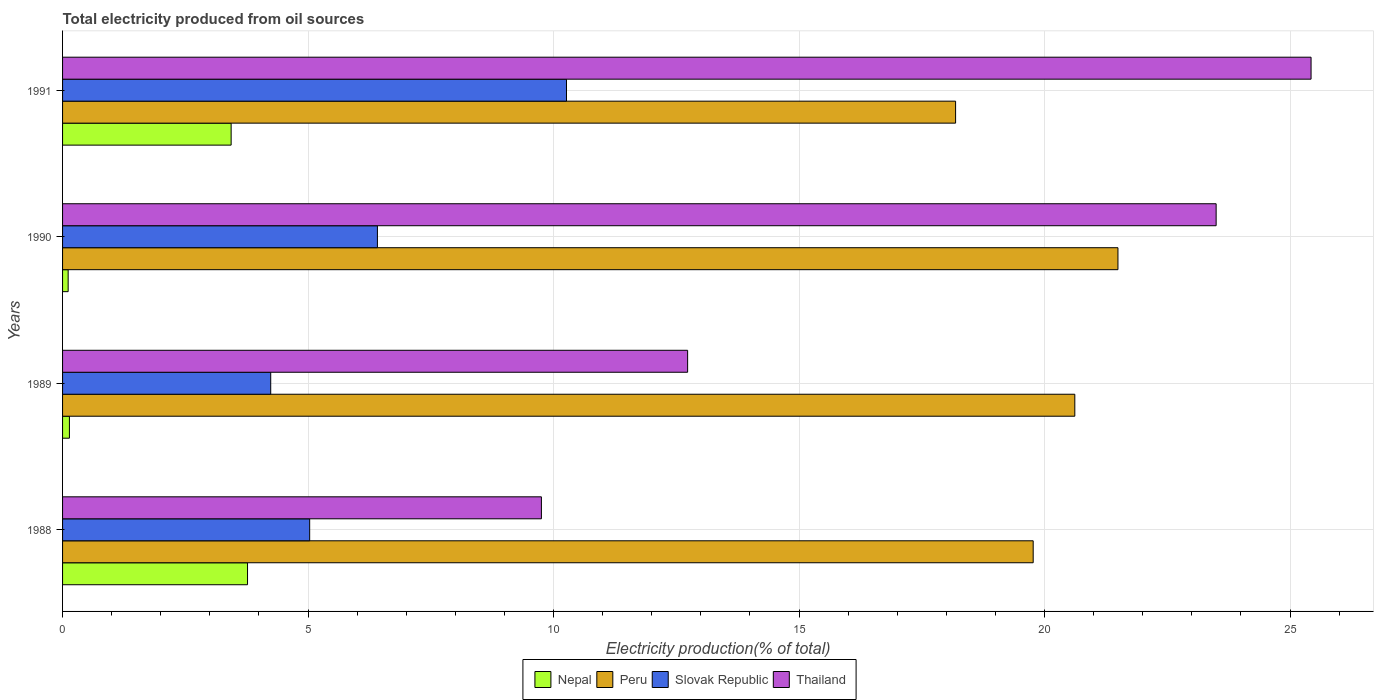How many different coloured bars are there?
Your answer should be compact. 4. How many groups of bars are there?
Offer a terse response. 4. Are the number of bars per tick equal to the number of legend labels?
Give a very brief answer. Yes. Are the number of bars on each tick of the Y-axis equal?
Your response must be concise. Yes. How many bars are there on the 4th tick from the top?
Make the answer very short. 4. What is the label of the 3rd group of bars from the top?
Offer a terse response. 1989. In how many cases, is the number of bars for a given year not equal to the number of legend labels?
Make the answer very short. 0. What is the total electricity produced in Slovak Republic in 1990?
Provide a succinct answer. 6.41. Across all years, what is the maximum total electricity produced in Nepal?
Make the answer very short. 3.77. Across all years, what is the minimum total electricity produced in Thailand?
Keep it short and to the point. 9.75. In which year was the total electricity produced in Peru maximum?
Keep it short and to the point. 1990. In which year was the total electricity produced in Slovak Republic minimum?
Give a very brief answer. 1989. What is the total total electricity produced in Thailand in the graph?
Keep it short and to the point. 71.41. What is the difference between the total electricity produced in Thailand in 1988 and that in 1991?
Provide a short and direct response. -15.68. What is the difference between the total electricity produced in Thailand in 1990 and the total electricity produced in Slovak Republic in 1991?
Give a very brief answer. 13.23. What is the average total electricity produced in Peru per year?
Ensure brevity in your answer.  20.02. In the year 1988, what is the difference between the total electricity produced in Peru and total electricity produced in Slovak Republic?
Provide a short and direct response. 14.74. In how many years, is the total electricity produced in Peru greater than 4 %?
Provide a succinct answer. 4. What is the ratio of the total electricity produced in Peru in 1990 to that in 1991?
Ensure brevity in your answer.  1.18. What is the difference between the highest and the second highest total electricity produced in Thailand?
Ensure brevity in your answer.  1.93. What is the difference between the highest and the lowest total electricity produced in Nepal?
Your answer should be very brief. 3.65. In how many years, is the total electricity produced in Slovak Republic greater than the average total electricity produced in Slovak Republic taken over all years?
Your response must be concise. 1. Is the sum of the total electricity produced in Slovak Republic in 1989 and 1990 greater than the maximum total electricity produced in Peru across all years?
Make the answer very short. No. Is it the case that in every year, the sum of the total electricity produced in Slovak Republic and total electricity produced in Nepal is greater than the sum of total electricity produced in Peru and total electricity produced in Thailand?
Your answer should be compact. No. How many years are there in the graph?
Provide a succinct answer. 4. What is the difference between two consecutive major ticks on the X-axis?
Give a very brief answer. 5. How many legend labels are there?
Provide a short and direct response. 4. What is the title of the graph?
Your response must be concise. Total electricity produced from oil sources. Does "Mauritania" appear as one of the legend labels in the graph?
Provide a succinct answer. No. What is the label or title of the X-axis?
Provide a succinct answer. Electricity production(% of total). What is the Electricity production(% of total) in Nepal in 1988?
Your answer should be compact. 3.77. What is the Electricity production(% of total) in Peru in 1988?
Provide a succinct answer. 19.77. What is the Electricity production(% of total) of Slovak Republic in 1988?
Offer a terse response. 5.03. What is the Electricity production(% of total) of Thailand in 1988?
Make the answer very short. 9.75. What is the Electricity production(% of total) in Nepal in 1989?
Offer a terse response. 0.14. What is the Electricity production(% of total) of Peru in 1989?
Make the answer very short. 20.62. What is the Electricity production(% of total) of Slovak Republic in 1989?
Give a very brief answer. 4.24. What is the Electricity production(% of total) in Thailand in 1989?
Offer a terse response. 12.73. What is the Electricity production(% of total) of Nepal in 1990?
Your answer should be compact. 0.11. What is the Electricity production(% of total) in Peru in 1990?
Your response must be concise. 21.49. What is the Electricity production(% of total) of Slovak Republic in 1990?
Provide a succinct answer. 6.41. What is the Electricity production(% of total) of Thailand in 1990?
Offer a very short reply. 23.49. What is the Electricity production(% of total) in Nepal in 1991?
Offer a very short reply. 3.43. What is the Electricity production(% of total) in Peru in 1991?
Provide a short and direct response. 18.19. What is the Electricity production(% of total) of Slovak Republic in 1991?
Ensure brevity in your answer.  10.26. What is the Electricity production(% of total) of Thailand in 1991?
Ensure brevity in your answer.  25.43. Across all years, what is the maximum Electricity production(% of total) of Nepal?
Your answer should be very brief. 3.77. Across all years, what is the maximum Electricity production(% of total) in Peru?
Provide a short and direct response. 21.49. Across all years, what is the maximum Electricity production(% of total) in Slovak Republic?
Your answer should be compact. 10.26. Across all years, what is the maximum Electricity production(% of total) in Thailand?
Offer a very short reply. 25.43. Across all years, what is the minimum Electricity production(% of total) of Nepal?
Give a very brief answer. 0.11. Across all years, what is the minimum Electricity production(% of total) of Peru?
Make the answer very short. 18.19. Across all years, what is the minimum Electricity production(% of total) of Slovak Republic?
Make the answer very short. 4.24. Across all years, what is the minimum Electricity production(% of total) of Thailand?
Your answer should be compact. 9.75. What is the total Electricity production(% of total) of Nepal in the graph?
Offer a terse response. 7.45. What is the total Electricity production(% of total) in Peru in the graph?
Make the answer very short. 80.07. What is the total Electricity production(% of total) in Slovak Republic in the graph?
Offer a terse response. 25.95. What is the total Electricity production(% of total) in Thailand in the graph?
Make the answer very short. 71.41. What is the difference between the Electricity production(% of total) in Nepal in 1988 and that in 1989?
Offer a terse response. 3.63. What is the difference between the Electricity production(% of total) of Peru in 1988 and that in 1989?
Provide a succinct answer. -0.85. What is the difference between the Electricity production(% of total) in Slovak Republic in 1988 and that in 1989?
Offer a terse response. 0.79. What is the difference between the Electricity production(% of total) of Thailand in 1988 and that in 1989?
Offer a terse response. -2.98. What is the difference between the Electricity production(% of total) in Nepal in 1988 and that in 1990?
Your response must be concise. 3.65. What is the difference between the Electricity production(% of total) in Peru in 1988 and that in 1990?
Provide a succinct answer. -1.73. What is the difference between the Electricity production(% of total) of Slovak Republic in 1988 and that in 1990?
Offer a terse response. -1.38. What is the difference between the Electricity production(% of total) of Thailand in 1988 and that in 1990?
Your answer should be compact. -13.74. What is the difference between the Electricity production(% of total) in Nepal in 1988 and that in 1991?
Your answer should be compact. 0.33. What is the difference between the Electricity production(% of total) in Peru in 1988 and that in 1991?
Provide a short and direct response. 1.58. What is the difference between the Electricity production(% of total) of Slovak Republic in 1988 and that in 1991?
Ensure brevity in your answer.  -5.23. What is the difference between the Electricity production(% of total) in Thailand in 1988 and that in 1991?
Your answer should be compact. -15.68. What is the difference between the Electricity production(% of total) in Nepal in 1989 and that in 1990?
Offer a very short reply. 0.03. What is the difference between the Electricity production(% of total) of Peru in 1989 and that in 1990?
Give a very brief answer. -0.88. What is the difference between the Electricity production(% of total) in Slovak Republic in 1989 and that in 1990?
Your response must be concise. -2.17. What is the difference between the Electricity production(% of total) in Thailand in 1989 and that in 1990?
Your response must be concise. -10.76. What is the difference between the Electricity production(% of total) of Nepal in 1989 and that in 1991?
Ensure brevity in your answer.  -3.29. What is the difference between the Electricity production(% of total) of Peru in 1989 and that in 1991?
Offer a terse response. 2.43. What is the difference between the Electricity production(% of total) in Slovak Republic in 1989 and that in 1991?
Your response must be concise. -6.02. What is the difference between the Electricity production(% of total) in Thailand in 1989 and that in 1991?
Give a very brief answer. -12.7. What is the difference between the Electricity production(% of total) in Nepal in 1990 and that in 1991?
Your response must be concise. -3.32. What is the difference between the Electricity production(% of total) of Peru in 1990 and that in 1991?
Your response must be concise. 3.31. What is the difference between the Electricity production(% of total) of Slovak Republic in 1990 and that in 1991?
Make the answer very short. -3.85. What is the difference between the Electricity production(% of total) of Thailand in 1990 and that in 1991?
Offer a very short reply. -1.93. What is the difference between the Electricity production(% of total) of Nepal in 1988 and the Electricity production(% of total) of Peru in 1989?
Your response must be concise. -16.85. What is the difference between the Electricity production(% of total) in Nepal in 1988 and the Electricity production(% of total) in Slovak Republic in 1989?
Make the answer very short. -0.47. What is the difference between the Electricity production(% of total) in Nepal in 1988 and the Electricity production(% of total) in Thailand in 1989?
Offer a very short reply. -8.96. What is the difference between the Electricity production(% of total) of Peru in 1988 and the Electricity production(% of total) of Slovak Republic in 1989?
Your answer should be compact. 15.53. What is the difference between the Electricity production(% of total) in Peru in 1988 and the Electricity production(% of total) in Thailand in 1989?
Provide a succinct answer. 7.04. What is the difference between the Electricity production(% of total) in Slovak Republic in 1988 and the Electricity production(% of total) in Thailand in 1989?
Provide a short and direct response. -7.7. What is the difference between the Electricity production(% of total) of Nepal in 1988 and the Electricity production(% of total) of Peru in 1990?
Your answer should be compact. -17.73. What is the difference between the Electricity production(% of total) in Nepal in 1988 and the Electricity production(% of total) in Slovak Republic in 1990?
Provide a succinct answer. -2.65. What is the difference between the Electricity production(% of total) in Nepal in 1988 and the Electricity production(% of total) in Thailand in 1990?
Provide a succinct answer. -19.73. What is the difference between the Electricity production(% of total) in Peru in 1988 and the Electricity production(% of total) in Slovak Republic in 1990?
Your response must be concise. 13.36. What is the difference between the Electricity production(% of total) in Peru in 1988 and the Electricity production(% of total) in Thailand in 1990?
Your response must be concise. -3.73. What is the difference between the Electricity production(% of total) of Slovak Republic in 1988 and the Electricity production(% of total) of Thailand in 1990?
Offer a terse response. -18.46. What is the difference between the Electricity production(% of total) in Nepal in 1988 and the Electricity production(% of total) in Peru in 1991?
Your response must be concise. -14.42. What is the difference between the Electricity production(% of total) of Nepal in 1988 and the Electricity production(% of total) of Slovak Republic in 1991?
Your response must be concise. -6.5. What is the difference between the Electricity production(% of total) in Nepal in 1988 and the Electricity production(% of total) in Thailand in 1991?
Offer a terse response. -21.66. What is the difference between the Electricity production(% of total) in Peru in 1988 and the Electricity production(% of total) in Slovak Republic in 1991?
Give a very brief answer. 9.5. What is the difference between the Electricity production(% of total) in Peru in 1988 and the Electricity production(% of total) in Thailand in 1991?
Your answer should be very brief. -5.66. What is the difference between the Electricity production(% of total) of Slovak Republic in 1988 and the Electricity production(% of total) of Thailand in 1991?
Offer a terse response. -20.39. What is the difference between the Electricity production(% of total) of Nepal in 1989 and the Electricity production(% of total) of Peru in 1990?
Keep it short and to the point. -21.36. What is the difference between the Electricity production(% of total) in Nepal in 1989 and the Electricity production(% of total) in Slovak Republic in 1990?
Make the answer very short. -6.27. What is the difference between the Electricity production(% of total) in Nepal in 1989 and the Electricity production(% of total) in Thailand in 1990?
Your response must be concise. -23.36. What is the difference between the Electricity production(% of total) in Peru in 1989 and the Electricity production(% of total) in Slovak Republic in 1990?
Offer a very short reply. 14.2. What is the difference between the Electricity production(% of total) of Peru in 1989 and the Electricity production(% of total) of Thailand in 1990?
Keep it short and to the point. -2.88. What is the difference between the Electricity production(% of total) in Slovak Republic in 1989 and the Electricity production(% of total) in Thailand in 1990?
Provide a succinct answer. -19.26. What is the difference between the Electricity production(% of total) in Nepal in 1989 and the Electricity production(% of total) in Peru in 1991?
Ensure brevity in your answer.  -18.05. What is the difference between the Electricity production(% of total) in Nepal in 1989 and the Electricity production(% of total) in Slovak Republic in 1991?
Offer a very short reply. -10.12. What is the difference between the Electricity production(% of total) in Nepal in 1989 and the Electricity production(% of total) in Thailand in 1991?
Give a very brief answer. -25.29. What is the difference between the Electricity production(% of total) of Peru in 1989 and the Electricity production(% of total) of Slovak Republic in 1991?
Provide a succinct answer. 10.35. What is the difference between the Electricity production(% of total) of Peru in 1989 and the Electricity production(% of total) of Thailand in 1991?
Keep it short and to the point. -4.81. What is the difference between the Electricity production(% of total) in Slovak Republic in 1989 and the Electricity production(% of total) in Thailand in 1991?
Provide a succinct answer. -21.19. What is the difference between the Electricity production(% of total) in Nepal in 1990 and the Electricity production(% of total) in Peru in 1991?
Your answer should be very brief. -18.07. What is the difference between the Electricity production(% of total) of Nepal in 1990 and the Electricity production(% of total) of Slovak Republic in 1991?
Offer a very short reply. -10.15. What is the difference between the Electricity production(% of total) of Nepal in 1990 and the Electricity production(% of total) of Thailand in 1991?
Your answer should be very brief. -25.31. What is the difference between the Electricity production(% of total) of Peru in 1990 and the Electricity production(% of total) of Slovak Republic in 1991?
Your response must be concise. 11.23. What is the difference between the Electricity production(% of total) of Peru in 1990 and the Electricity production(% of total) of Thailand in 1991?
Your response must be concise. -3.93. What is the difference between the Electricity production(% of total) of Slovak Republic in 1990 and the Electricity production(% of total) of Thailand in 1991?
Make the answer very short. -19.02. What is the average Electricity production(% of total) in Nepal per year?
Offer a very short reply. 1.86. What is the average Electricity production(% of total) of Peru per year?
Provide a succinct answer. 20.02. What is the average Electricity production(% of total) of Slovak Republic per year?
Your response must be concise. 6.49. What is the average Electricity production(% of total) of Thailand per year?
Your answer should be very brief. 17.85. In the year 1988, what is the difference between the Electricity production(% of total) in Nepal and Electricity production(% of total) in Peru?
Give a very brief answer. -16. In the year 1988, what is the difference between the Electricity production(% of total) in Nepal and Electricity production(% of total) in Slovak Republic?
Give a very brief answer. -1.27. In the year 1988, what is the difference between the Electricity production(% of total) in Nepal and Electricity production(% of total) in Thailand?
Provide a short and direct response. -5.99. In the year 1988, what is the difference between the Electricity production(% of total) of Peru and Electricity production(% of total) of Slovak Republic?
Your response must be concise. 14.74. In the year 1988, what is the difference between the Electricity production(% of total) of Peru and Electricity production(% of total) of Thailand?
Offer a terse response. 10.02. In the year 1988, what is the difference between the Electricity production(% of total) in Slovak Republic and Electricity production(% of total) in Thailand?
Keep it short and to the point. -4.72. In the year 1989, what is the difference between the Electricity production(% of total) in Nepal and Electricity production(% of total) in Peru?
Your answer should be compact. -20.48. In the year 1989, what is the difference between the Electricity production(% of total) in Nepal and Electricity production(% of total) in Slovak Republic?
Ensure brevity in your answer.  -4.1. In the year 1989, what is the difference between the Electricity production(% of total) in Nepal and Electricity production(% of total) in Thailand?
Offer a very short reply. -12.59. In the year 1989, what is the difference between the Electricity production(% of total) in Peru and Electricity production(% of total) in Slovak Republic?
Offer a terse response. 16.38. In the year 1989, what is the difference between the Electricity production(% of total) in Peru and Electricity production(% of total) in Thailand?
Provide a short and direct response. 7.89. In the year 1989, what is the difference between the Electricity production(% of total) in Slovak Republic and Electricity production(% of total) in Thailand?
Your answer should be compact. -8.49. In the year 1990, what is the difference between the Electricity production(% of total) in Nepal and Electricity production(% of total) in Peru?
Offer a terse response. -21.38. In the year 1990, what is the difference between the Electricity production(% of total) in Nepal and Electricity production(% of total) in Slovak Republic?
Your answer should be compact. -6.3. In the year 1990, what is the difference between the Electricity production(% of total) in Nepal and Electricity production(% of total) in Thailand?
Your response must be concise. -23.38. In the year 1990, what is the difference between the Electricity production(% of total) of Peru and Electricity production(% of total) of Slovak Republic?
Provide a short and direct response. 15.08. In the year 1990, what is the difference between the Electricity production(% of total) of Peru and Electricity production(% of total) of Thailand?
Your response must be concise. -2. In the year 1990, what is the difference between the Electricity production(% of total) of Slovak Republic and Electricity production(% of total) of Thailand?
Make the answer very short. -17.08. In the year 1991, what is the difference between the Electricity production(% of total) of Nepal and Electricity production(% of total) of Peru?
Keep it short and to the point. -14.75. In the year 1991, what is the difference between the Electricity production(% of total) in Nepal and Electricity production(% of total) in Slovak Republic?
Give a very brief answer. -6.83. In the year 1991, what is the difference between the Electricity production(% of total) in Nepal and Electricity production(% of total) in Thailand?
Keep it short and to the point. -21.99. In the year 1991, what is the difference between the Electricity production(% of total) of Peru and Electricity production(% of total) of Slovak Republic?
Make the answer very short. 7.92. In the year 1991, what is the difference between the Electricity production(% of total) of Peru and Electricity production(% of total) of Thailand?
Your answer should be very brief. -7.24. In the year 1991, what is the difference between the Electricity production(% of total) of Slovak Republic and Electricity production(% of total) of Thailand?
Ensure brevity in your answer.  -15.16. What is the ratio of the Electricity production(% of total) of Nepal in 1988 to that in 1989?
Provide a short and direct response. 26.97. What is the ratio of the Electricity production(% of total) in Peru in 1988 to that in 1989?
Keep it short and to the point. 0.96. What is the ratio of the Electricity production(% of total) of Slovak Republic in 1988 to that in 1989?
Keep it short and to the point. 1.19. What is the ratio of the Electricity production(% of total) in Thailand in 1988 to that in 1989?
Your answer should be very brief. 0.77. What is the ratio of the Electricity production(% of total) of Nepal in 1988 to that in 1990?
Offer a very short reply. 33.08. What is the ratio of the Electricity production(% of total) of Peru in 1988 to that in 1990?
Offer a terse response. 0.92. What is the ratio of the Electricity production(% of total) in Slovak Republic in 1988 to that in 1990?
Make the answer very short. 0.78. What is the ratio of the Electricity production(% of total) in Thailand in 1988 to that in 1990?
Your answer should be compact. 0.42. What is the ratio of the Electricity production(% of total) of Nepal in 1988 to that in 1991?
Provide a short and direct response. 1.1. What is the ratio of the Electricity production(% of total) in Peru in 1988 to that in 1991?
Your answer should be compact. 1.09. What is the ratio of the Electricity production(% of total) of Slovak Republic in 1988 to that in 1991?
Your answer should be very brief. 0.49. What is the ratio of the Electricity production(% of total) of Thailand in 1988 to that in 1991?
Make the answer very short. 0.38. What is the ratio of the Electricity production(% of total) of Nepal in 1989 to that in 1990?
Ensure brevity in your answer.  1.23. What is the ratio of the Electricity production(% of total) of Peru in 1989 to that in 1990?
Your answer should be compact. 0.96. What is the ratio of the Electricity production(% of total) of Slovak Republic in 1989 to that in 1990?
Ensure brevity in your answer.  0.66. What is the ratio of the Electricity production(% of total) in Thailand in 1989 to that in 1990?
Your answer should be very brief. 0.54. What is the ratio of the Electricity production(% of total) in Nepal in 1989 to that in 1991?
Your response must be concise. 0.04. What is the ratio of the Electricity production(% of total) in Peru in 1989 to that in 1991?
Your answer should be very brief. 1.13. What is the ratio of the Electricity production(% of total) in Slovak Republic in 1989 to that in 1991?
Offer a very short reply. 0.41. What is the ratio of the Electricity production(% of total) in Thailand in 1989 to that in 1991?
Ensure brevity in your answer.  0.5. What is the ratio of the Electricity production(% of total) of Nepal in 1990 to that in 1991?
Ensure brevity in your answer.  0.03. What is the ratio of the Electricity production(% of total) of Peru in 1990 to that in 1991?
Your answer should be very brief. 1.18. What is the ratio of the Electricity production(% of total) in Slovak Republic in 1990 to that in 1991?
Provide a succinct answer. 0.62. What is the ratio of the Electricity production(% of total) of Thailand in 1990 to that in 1991?
Make the answer very short. 0.92. What is the difference between the highest and the second highest Electricity production(% of total) in Nepal?
Provide a succinct answer. 0.33. What is the difference between the highest and the second highest Electricity production(% of total) of Peru?
Your answer should be very brief. 0.88. What is the difference between the highest and the second highest Electricity production(% of total) of Slovak Republic?
Provide a short and direct response. 3.85. What is the difference between the highest and the second highest Electricity production(% of total) of Thailand?
Your response must be concise. 1.93. What is the difference between the highest and the lowest Electricity production(% of total) in Nepal?
Your answer should be very brief. 3.65. What is the difference between the highest and the lowest Electricity production(% of total) in Peru?
Keep it short and to the point. 3.31. What is the difference between the highest and the lowest Electricity production(% of total) of Slovak Republic?
Your answer should be very brief. 6.02. What is the difference between the highest and the lowest Electricity production(% of total) in Thailand?
Provide a short and direct response. 15.68. 